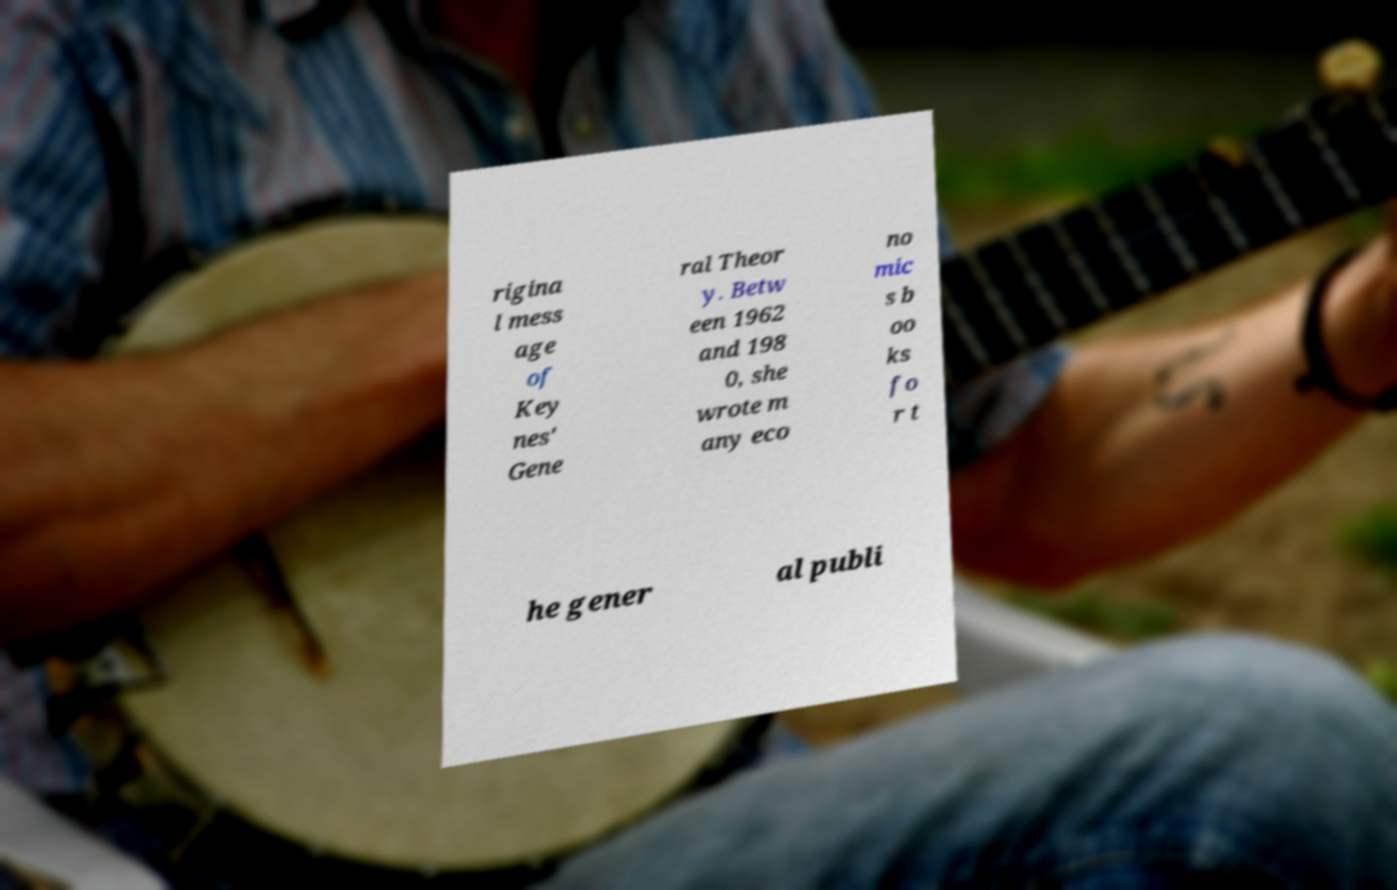Can you accurately transcribe the text from the provided image for me? rigina l mess age of Key nes' Gene ral Theor y. Betw een 1962 and 198 0, she wrote m any eco no mic s b oo ks fo r t he gener al publi 